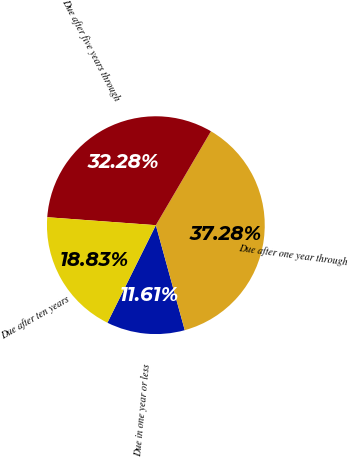Convert chart to OTSL. <chart><loc_0><loc_0><loc_500><loc_500><pie_chart><fcel>Due in one year or less<fcel>Due after one year through<fcel>Due after five years through<fcel>Due after ten years<nl><fcel>11.61%<fcel>37.28%<fcel>32.28%<fcel>18.83%<nl></chart> 